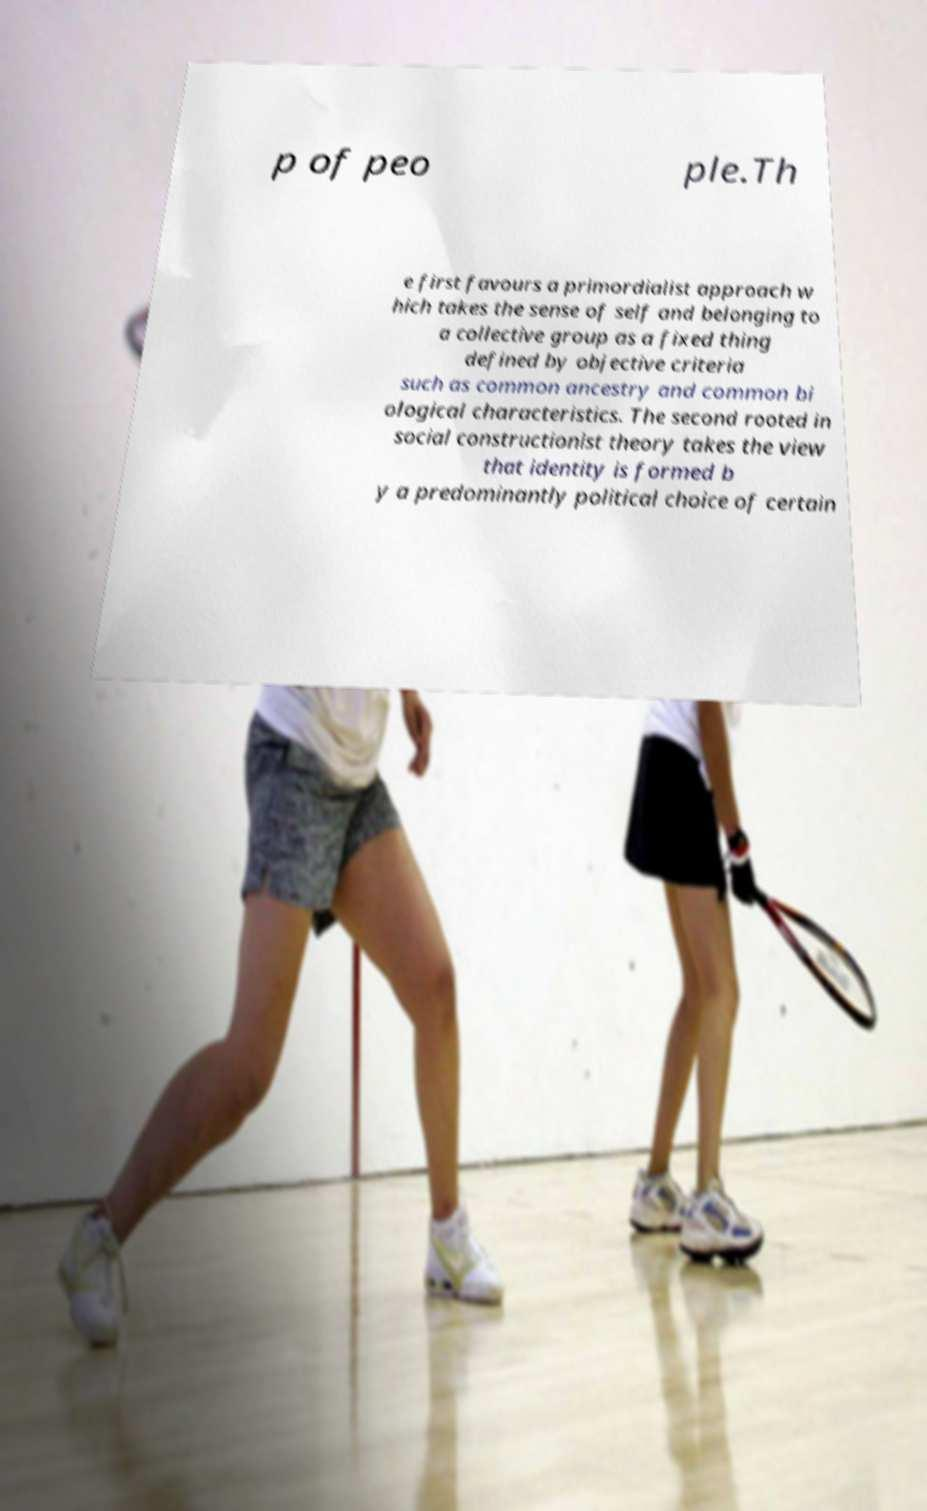I need the written content from this picture converted into text. Can you do that? p of peo ple.Th e first favours a primordialist approach w hich takes the sense of self and belonging to a collective group as a fixed thing defined by objective criteria such as common ancestry and common bi ological characteristics. The second rooted in social constructionist theory takes the view that identity is formed b y a predominantly political choice of certain 